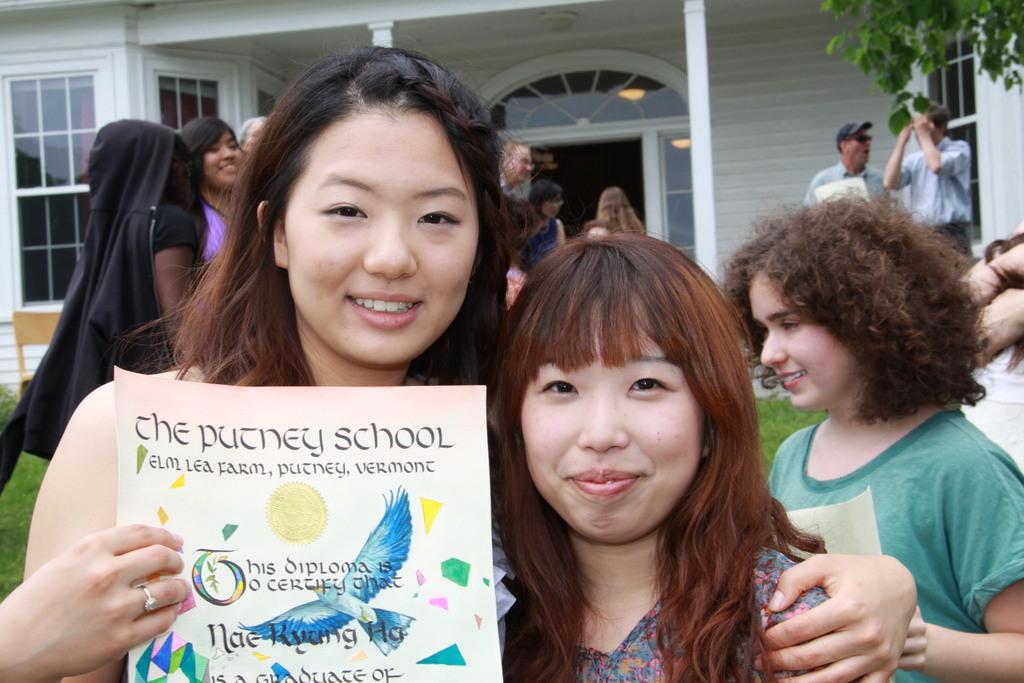Can you describe this image briefly? In this image there is a woman holding a poster in her hand. She is keeping her hand on the woman. Behind them there are few persons standing on the grass land. Right top there is a tree. Background there is a building. Left side there is a chair on the grassland. 